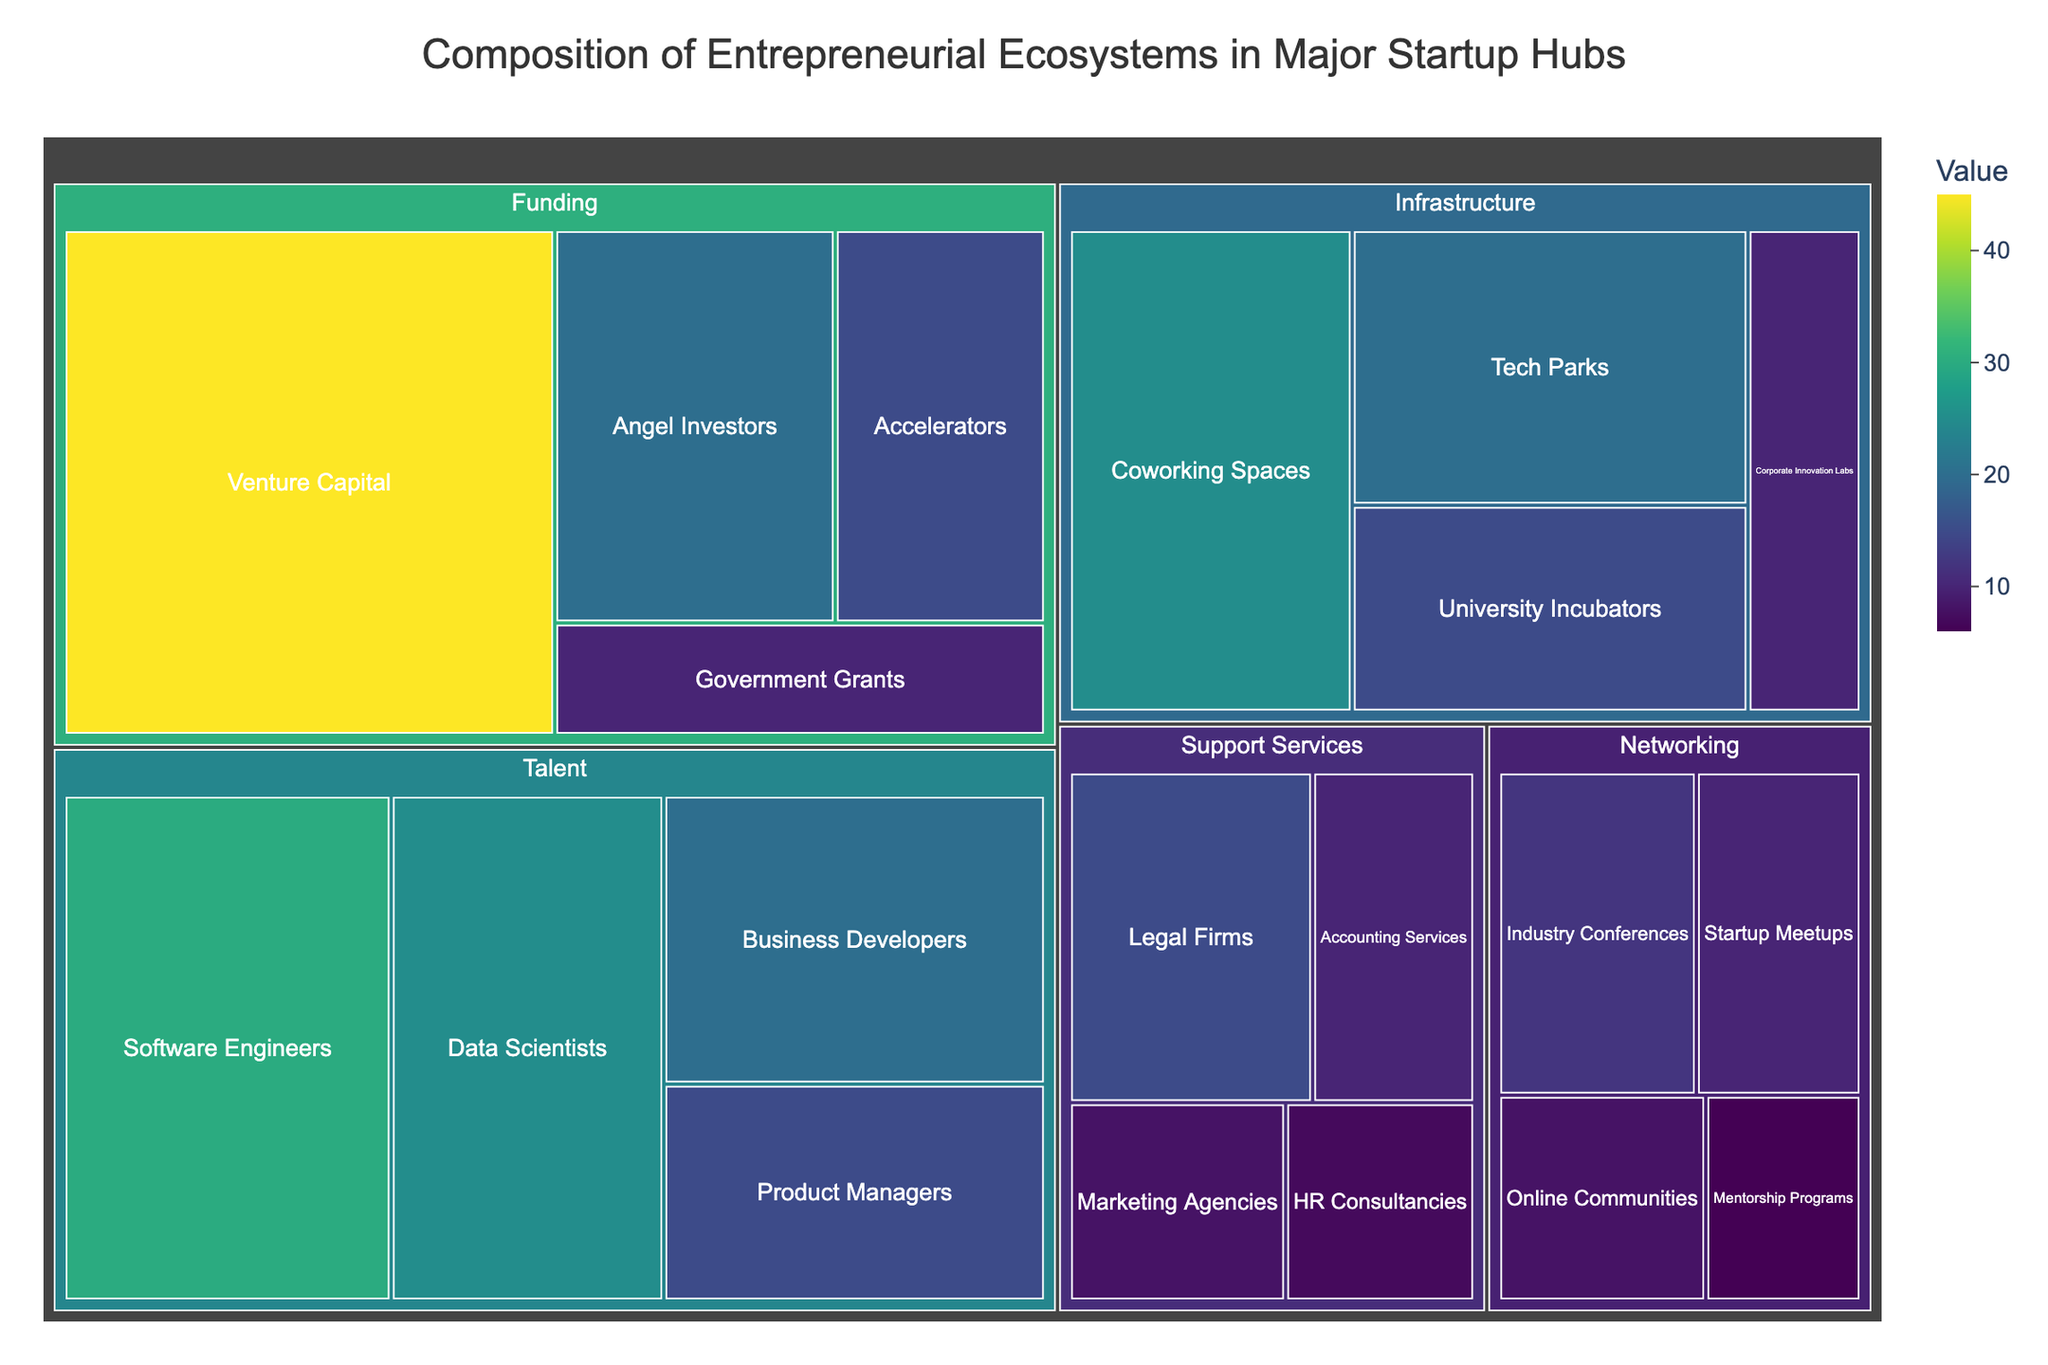What is the title of the Treemap? The title is usually found at the top of the Treemap. In this case, the title can be identified as 'Composition of Entrepreneurial Ecosystems in Major Startup Hubs'
Answer: Composition of Entrepreneurial Ecosystems in Major Startup Hubs Which subcategory in the 'Funding' category has the highest value? Look for the 'Funding' category and identify the subcategories under it. The 'Venture Capital' subcategory has the largest area, indicating the highest value within its category
Answer: Venture Capital What is the total value of the 'Talent' category? Sum the values of all subcategories within the 'Talent' category: Software Engineers (30) + Data Scientists (25) + Business Developers (20) + Product Managers (15). The total is 30 + 25 + 20 + 15 = 90
Answer: 90 How does the value of 'Tech Parks' compare to 'University Incubators'? Locate both subcategories under 'Infrastructure'. The value for Tech Parks is 20, and for University Incubators is 15. Compare these values directly: 20 (Tech Parks) is greater than 15 (University Incubators)
Answer: Tech Parks have a higher value than University Incubators What is the smallest value in the 'Support Services' category? List out the values of all subcategories under 'Support Services': Legal Firms (15), Accounting Services (10), Marketing Agencies (8), and HR Consultancies (7). The smallest value among these is 7
Answer: HR Consultancies What is the combined value of 'Online Communities' and 'Mentorship Programs' in the 'Networking' category? Find the values of both subcategories under 'Networking'. Online Communities have a value of 8, and Mentorship Programs have a value of 6. The combined value is 8 + 6 = 14
Answer: 14 In which category does 'Government Grants' fall, and what is its value? Identify and locate the 'Government Grants' subcategory. It falls under the 'Funding' category with a value of 10
Answer: Funding, 10 How many subcategories are there under 'Infrastructure'? Count the number of subcategories under the 'Infrastructure' category. These are Coworking Spaces, Tech Parks, University Incubators, and Corporate Innovation Labs, making a total of 4
Answer: 4 What is the average value of the subcategories under 'Support Services'? Calculate the average by summing all values of subcategories under 'Support Services' and dividing by the number of subcategories. The values are 15, 10, 8, and 7. The sum is 15 + 10 + 8 + 7 = 40. There are 4 subcategories, so the average is 40 / 4 = 10
Answer: 10 Which 'Networking' subcategory has the lowest value and what is its value? Find and compare all the subcategories under 'Networking'. Startup Meetups (10), Industry Conferences (12), Online Communities (8), and Mentorship Programs (6). The lowest value is 6, corresponding to Mentorship Programs
Answer: Mentorship Programs, 6 